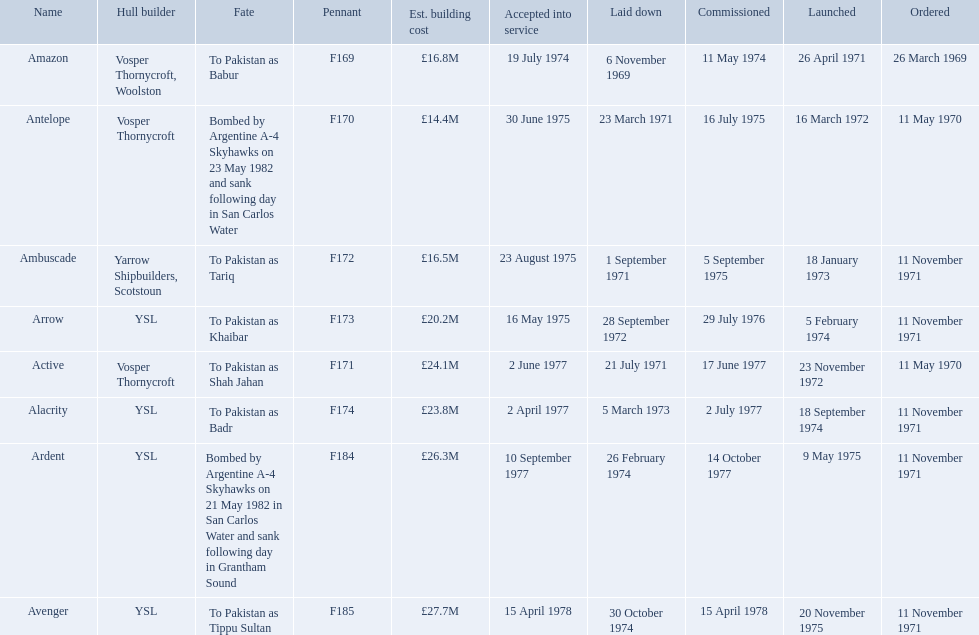Which ships cost more than ps25.0m to build? Ardent, Avenger. Of the ships listed in the answer above, which one cost the most to build? Avenger. 